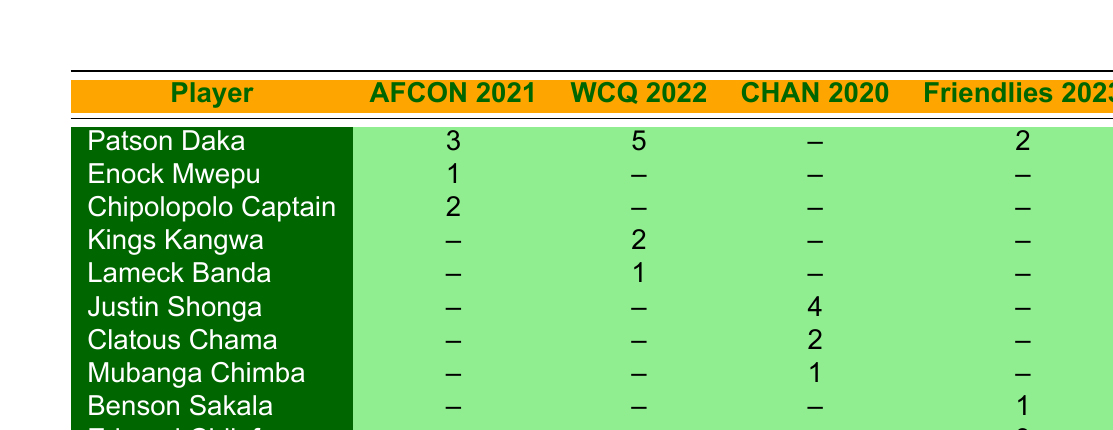What is the total number of goals scored by Patson Daka across all tournaments? To find the total goals scored by Patson Daka, we will sum the goals from each tournament: 3 (AFCON 2021) + 5 (WCQ 2022) + 2 (Friendlies 2023) = 10.
Answer: 10 Who scored the most goals in the FIFA World Cup Qualifiers 2022? From the table, Patson Daka scored 5 goals, while Kings Kangwa scored 2 goals and Lameck Banda scored 1 goal. Therefore, Patson Daka scored the most goals.
Answer: Patson Daka Which tournament did Justin Shonga score in, and how many goals did he score? According to the table, Justin Shonga scored 4 goals in the African Nations Championship 2020.
Answer: African Nations Championship, 4 Is it true that Enock Mwepu scored in all tournaments listed? Enock Mwepu scored 1 goal in AFCON 2021 but did not score in WCQ 2022, CHAN 2020, or Friendlies 2023. Therefore, it is false that he scored in all tournaments.
Answer: No What is the average number of goals scored by Zambian players in the International Friendlies 2023? In the Friendlies 2023, the goals scored are: Patson Daka (2), Benson Sakala (1), Edward Chilufya (3). First, we calculate the total: 2 + 1 + 3 = 6. There are 3 players, so the average is 6 / 3 = 2.
Answer: 2 Which player had the second-highest goal tally in the African Nations Championship 2020? In CHAN 2020, Justin Shonga scored 4 goals, Clatous Chama scored 2 goals, and Mubanga Chimba scored 1 goal. The second-highest is Clatous Chama with 2 goals.
Answer: Clatous Chama Did any player score in every tournament listed? By inspecting the table, no player has scored in every tournament. For example, Patson Daka has not played in CHAN 2020. Therefore, the statement is false.
Answer: No What is the combined total of goals scored by Lameck Banda and Kings Kangwa in the FIFA World Cup Qualifiers 2022? Lameck Banda scored 1 goal and Kings Kangwa scored 2 goals in WCQ 2022. Adding them together gives us 1 + 2 = 3.
Answer: 3 